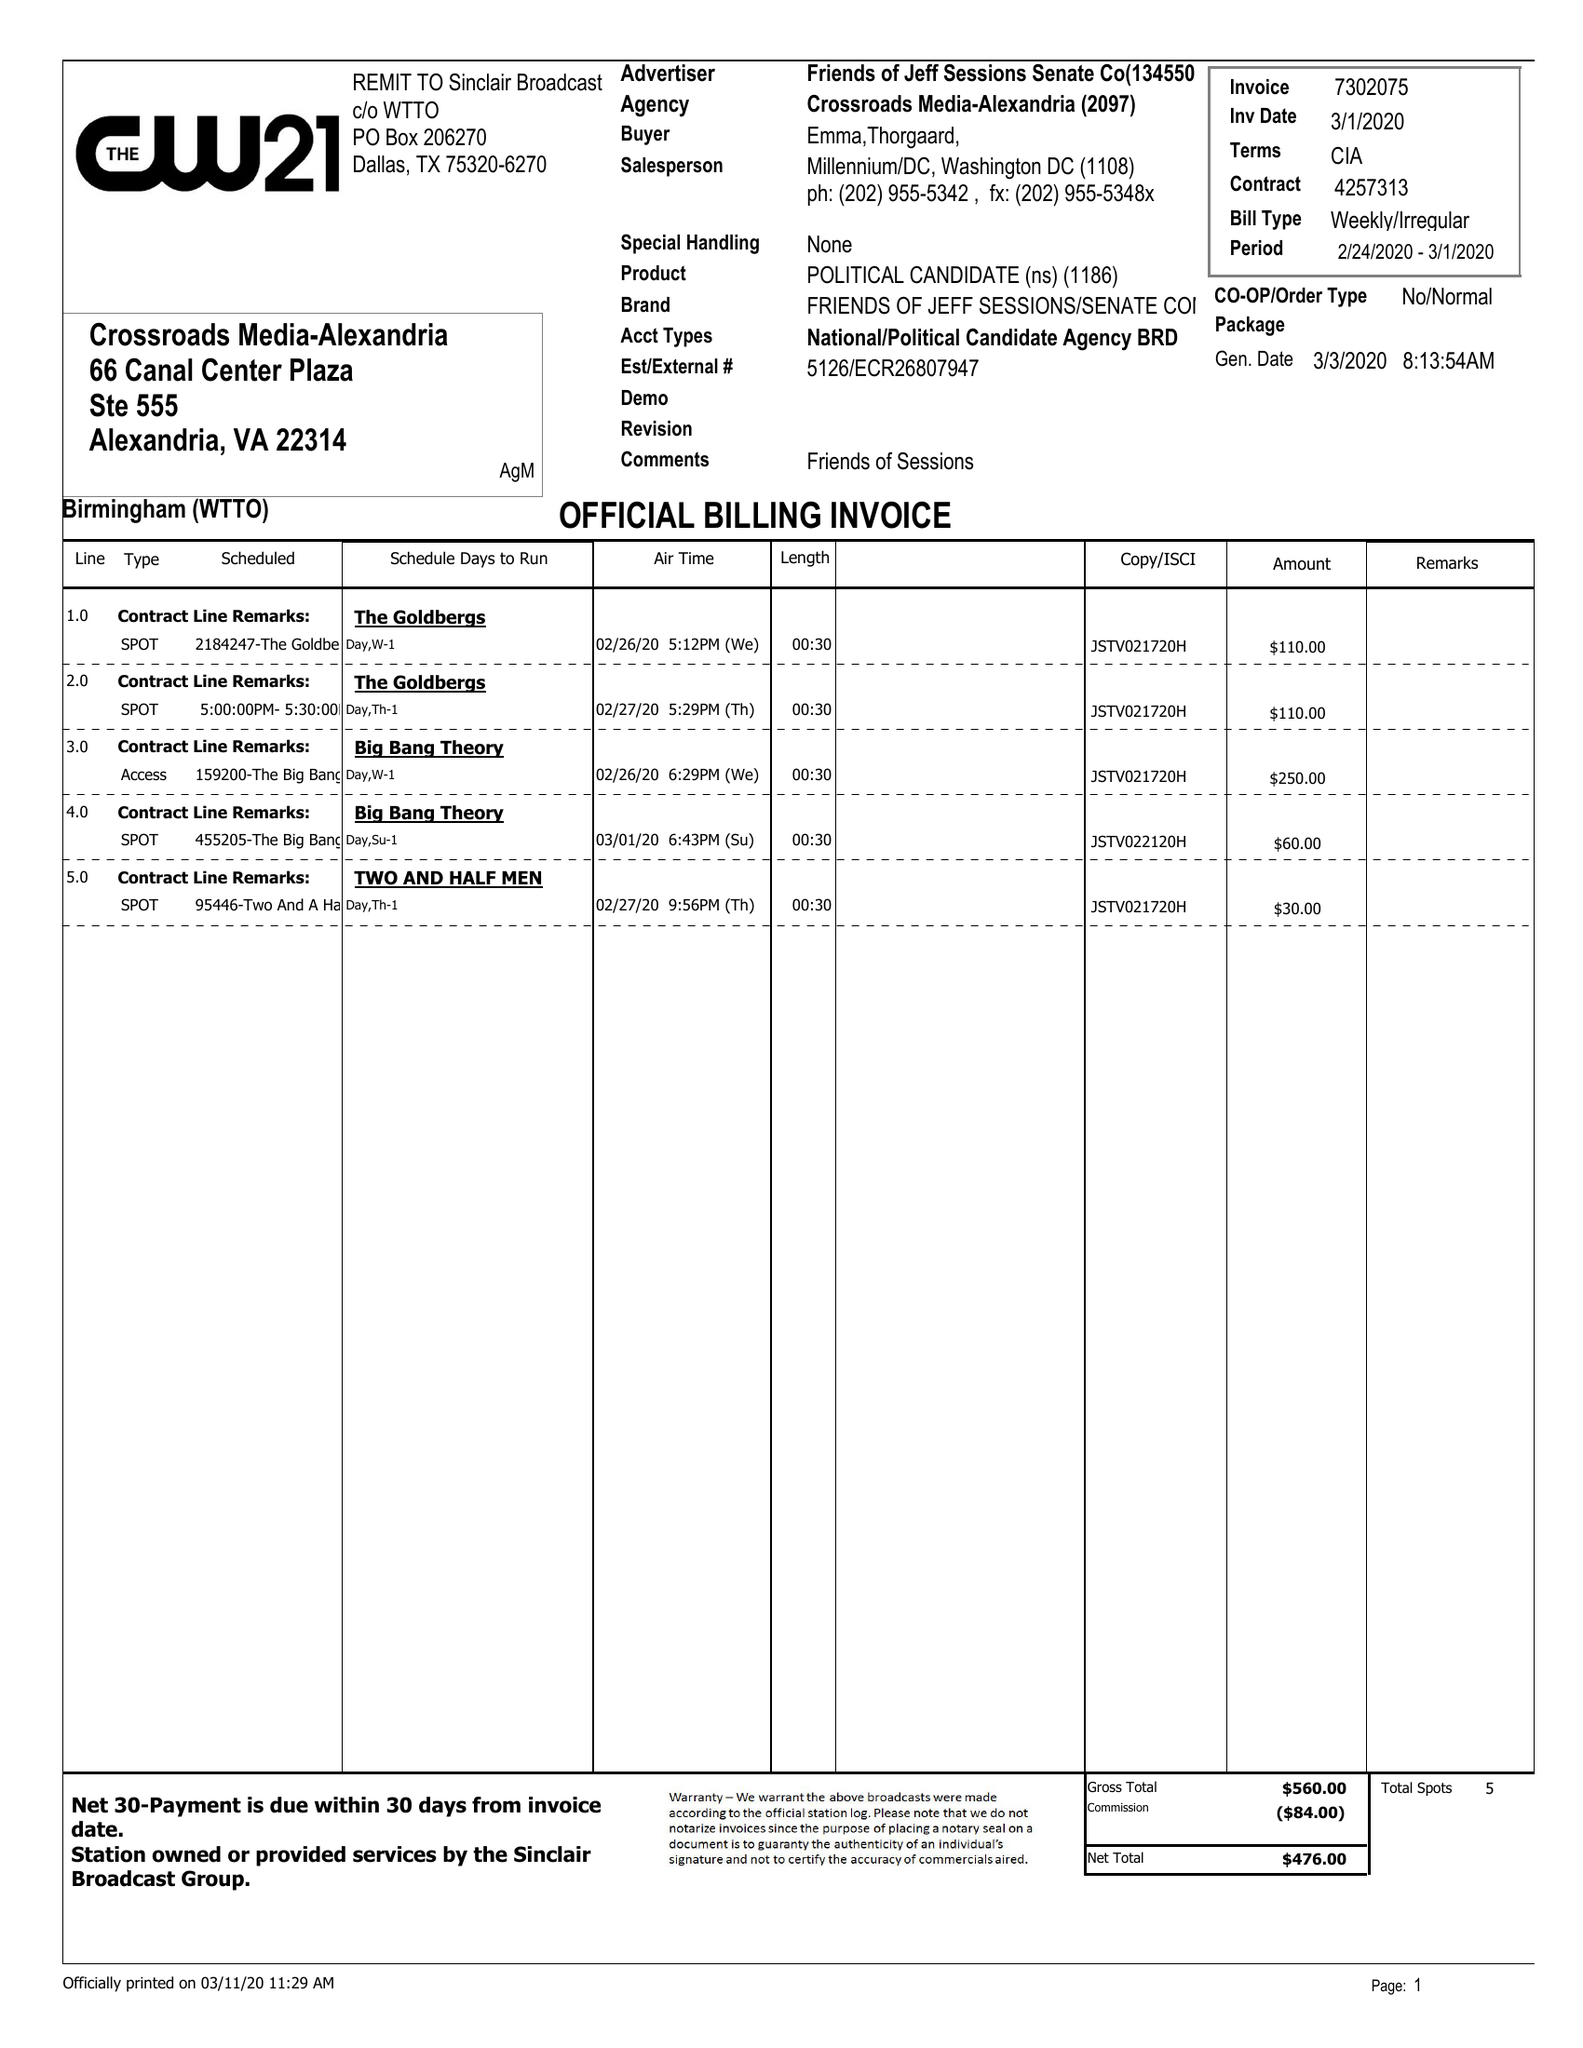What is the value for the advertiser?
Answer the question using a single word or phrase. FRIENDS OF JEFF SESSIONS SENATE CO 